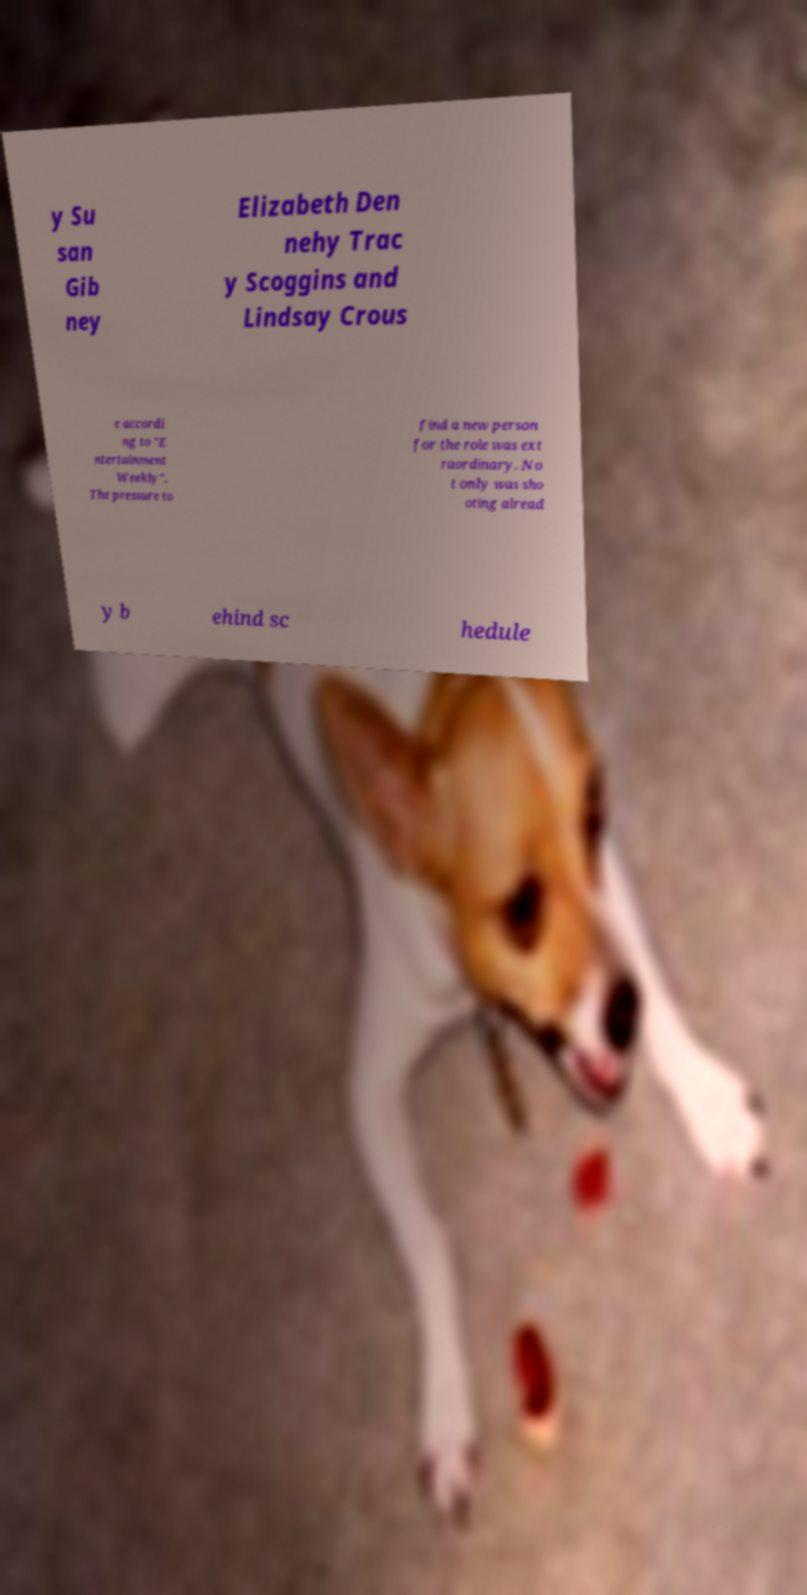I need the written content from this picture converted into text. Can you do that? y Su san Gib ney Elizabeth Den nehy Trac y Scoggins and Lindsay Crous e accordi ng to "E ntertainment Weekly". The pressure to find a new person for the role was ext raordinary. No t only was sho oting alread y b ehind sc hedule 